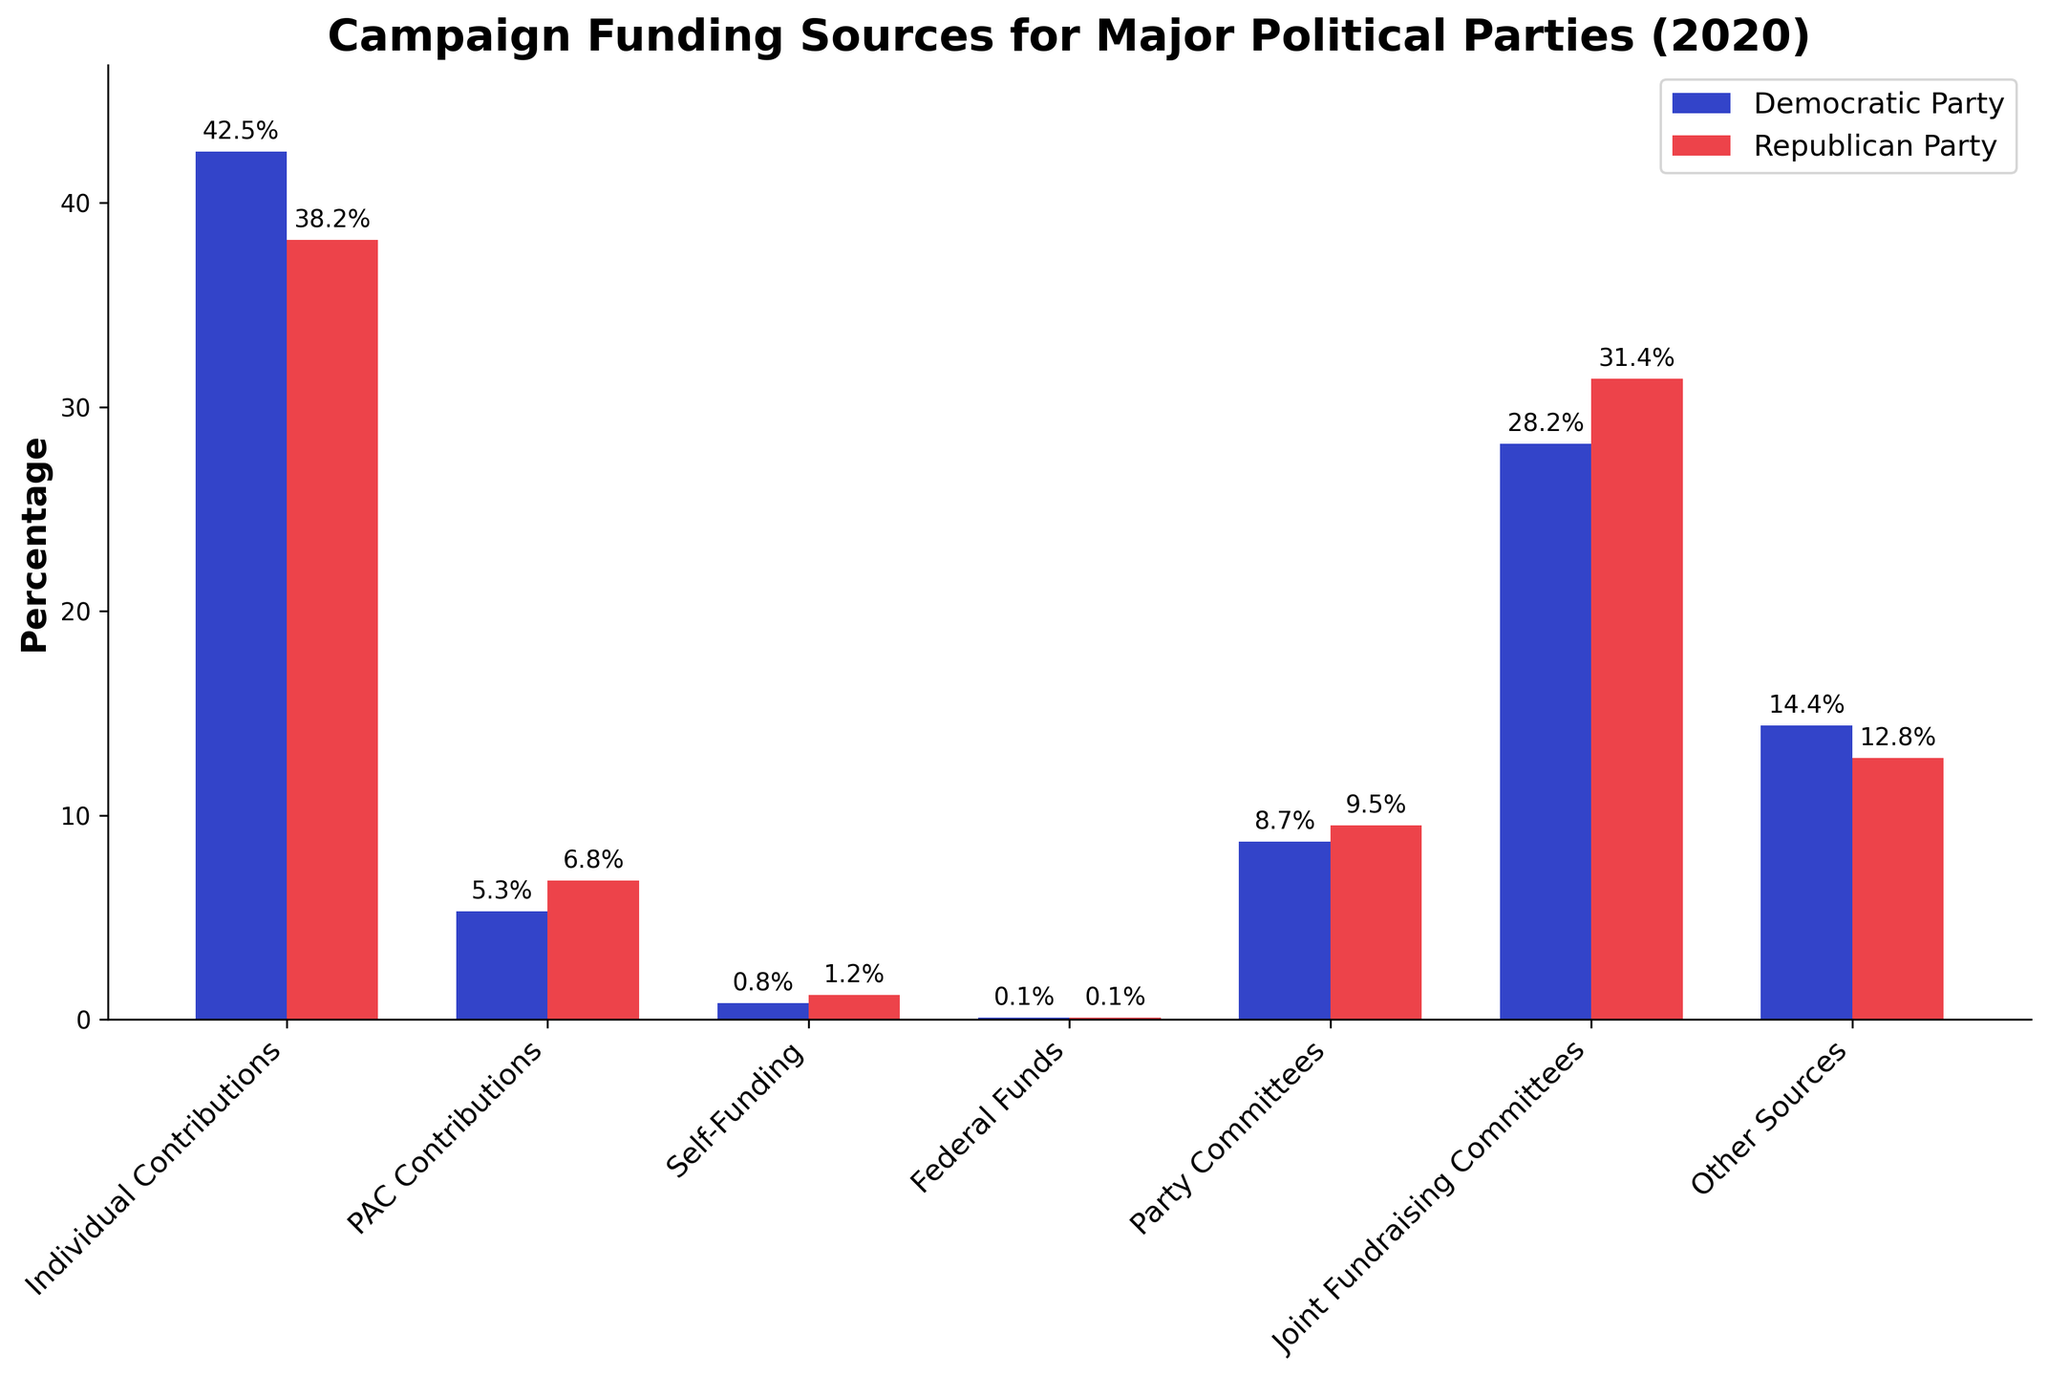Which party received a higher percentage from Individual Contributions? Look at the bar heights for Individual Contributions for both parties. The Democratic Party has a higher percentage at 42.5% compared to the Republican Party at 38.2%.
Answer: Democratic Party Which funding source had the lowest percentage for any party? Examine all the bars to find the smallest value. Federal Funds for both parties is the lowest at 0.1%.
Answer: Federal Funds What is the total percentage of contributions from PAC Contributions and Self-Funding for the Republican Party? Add the percentages for PAC Contributions and Self-Funding for the Republican Party: 6.8% + 1.2% = 8%.
Answer: 8% How much more does the Democratic Party receive from Individual Contributions compared to the Republican Party? Subtract the Republican Party's percentage of Individual Contributions from the Democratic Party's: 42.5% - 38.2% = 4.3%.
Answer: 4.3% Which funding source contributed nearly the same percentage to both parties? Compare the percentages for both parties across all funding sources. Federal Funds contributed the same percentage to both parties at 0.1%.
Answer: Federal Funds What is the average percentage contribution from Party Committees and Joint Fundraising Committees for the Democratic Party? Add the percentages for Party Committees and Joint Fundraising Committees for the Democratic Party and divide by 2: (8.7% + 28.2%) / 2 = 18.45%.
Answer: 18.45% Which party received more from Joint Fundraising Committees? Compare the bar heights for Joint Fundraising Committees. The Republican Party received more at 31.4% compared to the Democratic Party's 28.2%.
Answer: Republican Party What is the difference between the total percentage contributions from Individual Contributions and Other Sources for the Democratic Party? Add the percentages for Individual Contributions and Other Sources for the Democratic Party: 42.5% + 14.4% = 56.9%.
Answer: 56.9% What percentage do Party Committees contribute to the Republican Party's total funding? Look at the bar height for Party Committees for the Republican Party, which is 9.5%.
Answer: 9.5% By how much does the Republican Party's funding from Other Sources differ from the Democratic Party's? Subtract the percentage for Other Sources for the Republican Party from the Democratic Party: 14.4% - 12.8% = 1.6%.
Answer: 1.6% 